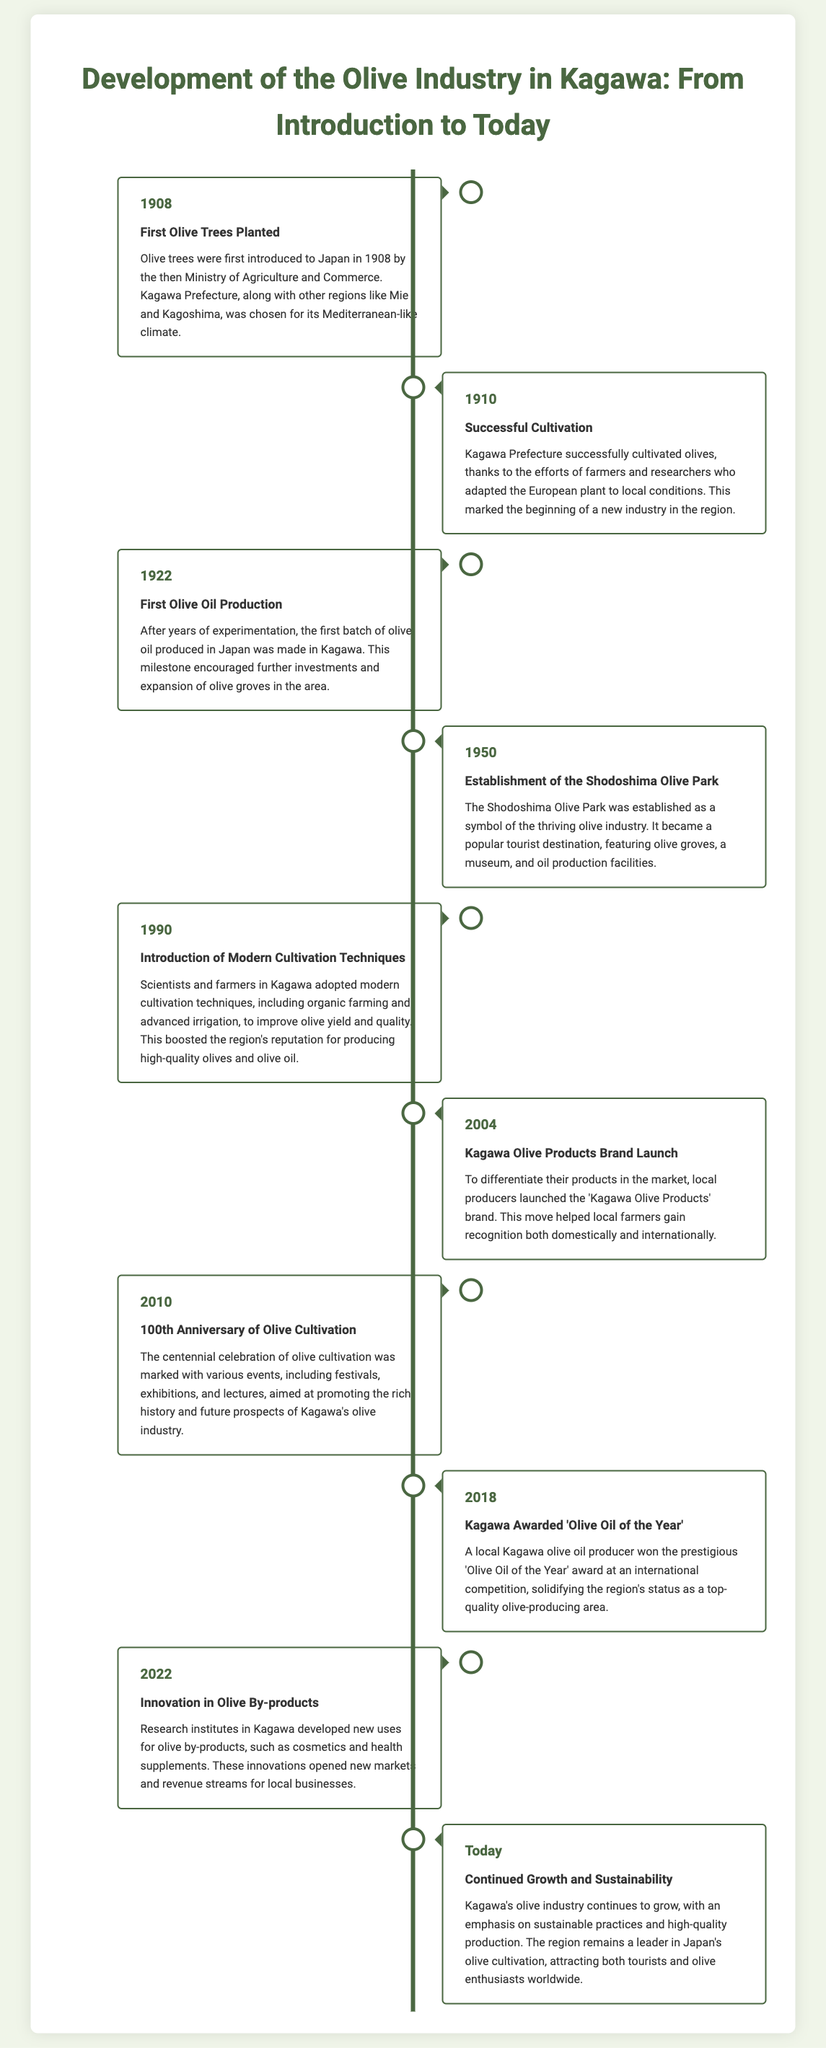What year were the first olive trees planted in Japan? The timeline indicates that the first olive trees were planted in 1908, as noted in the event description.
Answer: 1908 What marked the beginning of the olive industry in Kagawa? The successful cultivation of olives in 1910 marked the beginning of the olive industry, as stated in the event details.
Answer: Successful Cultivation In what year was the first batch of olive oil produced in Japan? According to the timeline, the first batch of olive oil was produced in Kagawa in 1922.
Answer: 1922 What significant facility was established in Kagawa in 1950? The establishment of the Shodoshima Olive Park in 1950 is highlighted as a symbol of the olive industry.
Answer: Shodoshima Olive Park What modern techniques were introduced in 1990 to improve olive yield? The timeline notes that modern cultivation techniques, including organic farming and advanced irrigation, were introduced in 1990.
Answer: Modern Cultivation Techniques What was launched in 2004 to differentiate local olive products? In 2004, the 'Kagawa Olive Products' brand was launched to help local producers stand out in the market.
Answer: Kagawa Olive Products What major celebration occurred in 2010 concerning olive cultivation? The timeline states that the 100th Anniversary of Olive Cultivation was celebrated with festivals and exhibitions in 2010.
Answer: 100th Anniversary Which award did a Kagawa olive oil producer win in 2018? The timeline mentions that a local producer was awarded 'Olive Oil of the Year' at an international competition in 2018.
Answer: Olive Oil of the Year What innovation occurred in Kagawa in 2022 related to olive by-products? The document highlights that research institutes developed new uses for olive by-products in 2022.
Answer: Innovation in Olive By-products What is the current emphasis of Kagawa's olive industry? The document states that the current emphasis is on sustainable practices and high-quality production.
Answer: Sustainability 